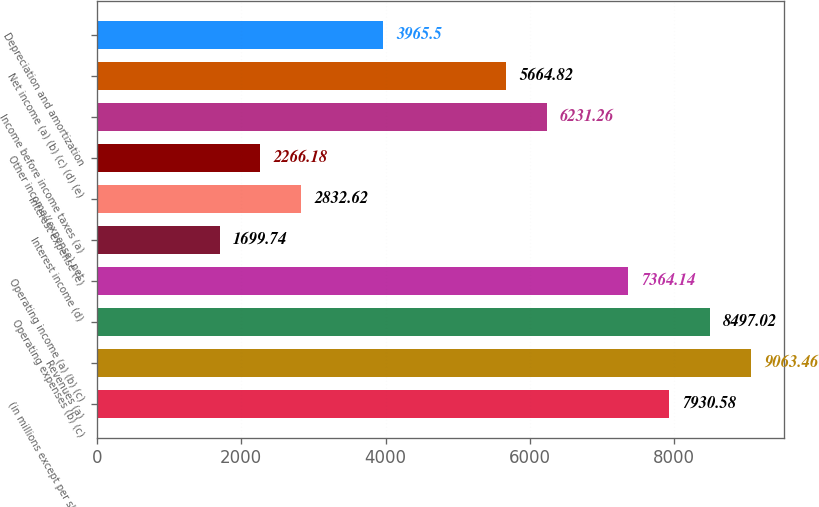Convert chart to OTSL. <chart><loc_0><loc_0><loc_500><loc_500><bar_chart><fcel>(in millions except per share<fcel>Revenues (a)<fcel>Operating expenses (b) (c)<fcel>Operating income (a) (b) (c)<fcel>Interest income (d)<fcel>Interest expense (e)<fcel>Other income/(expense) net<fcel>Income before income taxes (a)<fcel>Net income (a) (b) (c) (d) (e)<fcel>Depreciation and amortization<nl><fcel>7930.58<fcel>9063.46<fcel>8497.02<fcel>7364.14<fcel>1699.74<fcel>2832.62<fcel>2266.18<fcel>6231.26<fcel>5664.82<fcel>3965.5<nl></chart> 